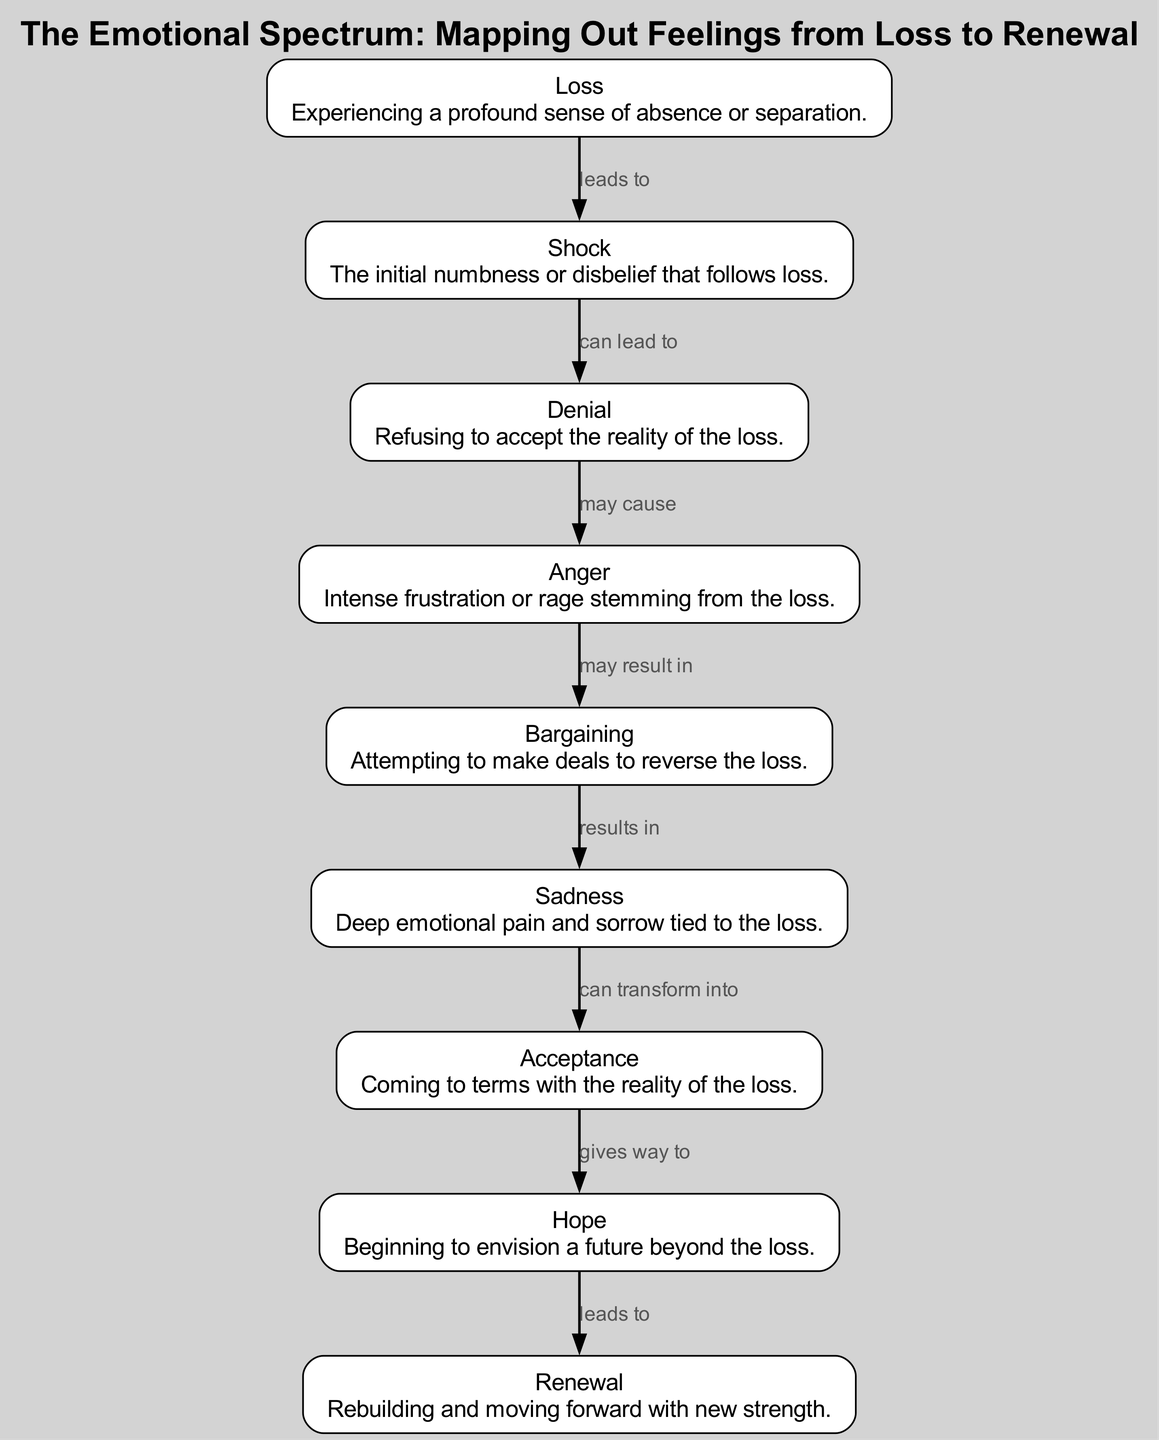What is the first node in the emotional spectrum? The diagram starts with the node "Loss," which is the initial emotion experienced in the spectrum of feelings.
Answer: Loss How many nodes are in the diagram? By counting the individual nodes listed in the diagram, there are nine distinct emotional states represented.
Answer: 9 What emotion follows Shock in the progression? From the edge that connects Shock to Denial, we can see that Denial directly follows Shock in the emotional journey.
Answer: Denial What can transform Sadness according to the diagram? The diagram indicates that Sadness can transform into Acceptance, which shows a progression from painful emotions to a more reconciled state.
Answer: Acceptance What is the relationship between Anger and Bargaining? The edge connects Anger to Bargaining, indicating that Anger may result in Bargaining as a response to the feelings of loss.
Answer: may result in Which node is the final stage in this emotional journey? The last node in the sequence is Renewal, indicating the completion of the process of healing and moving forward after experiencing loss.
Answer: Renewal What leads to Hope in the emotional spectrum? According to the diagram, Acceptance gives way to Hope, suggesting that coming to terms with loss leads to envisioning a brighter future.
Answer: gives way to Which two emotions are directly connected after Sadness? The edge from Sadness leads to Acceptance, establishing a clear sequence of emotional progression following Sadness.
Answer: Acceptance What may cause Anger as per the emotional spectrum? The diagram indicates that Denial may cause Anger, showing that refusal to accept a loss can lead to feelings of intense frustration.
Answer: may cause 